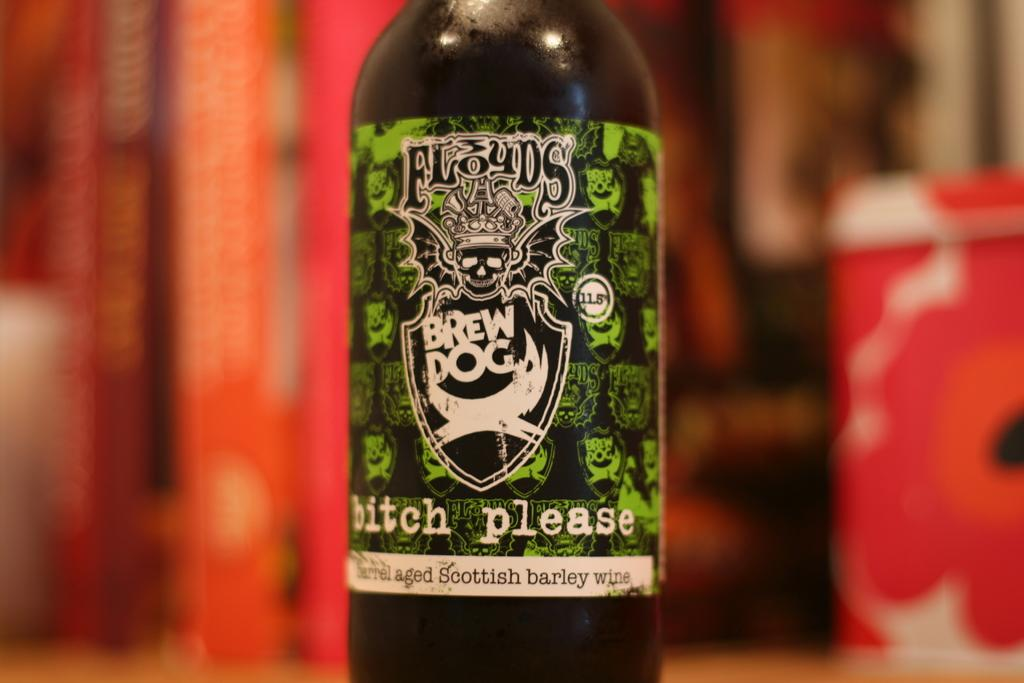<image>
Share a concise interpretation of the image provided. a bottle of Floyds beer has a green and white and black label 